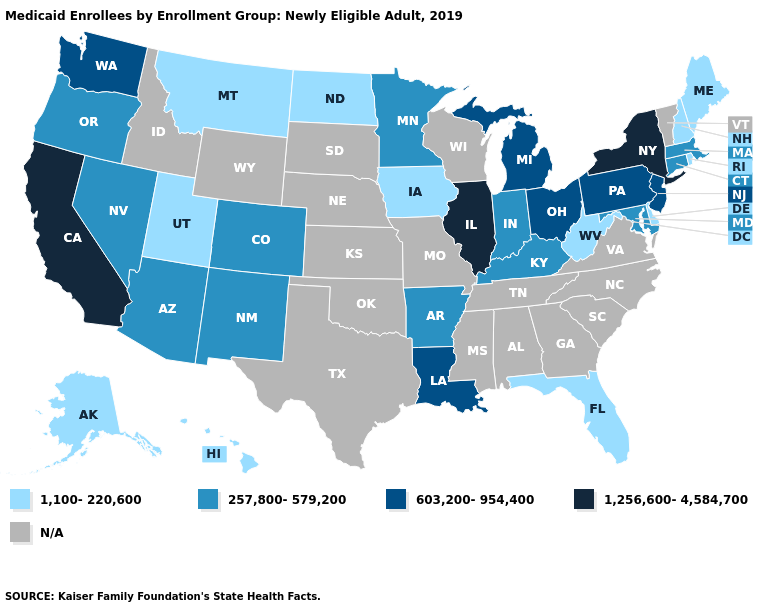Does Delaware have the lowest value in the USA?
Be succinct. Yes. Name the states that have a value in the range 1,256,600-4,584,700?
Be succinct. California, Illinois, New York. Does New Hampshire have the lowest value in the USA?
Short answer required. Yes. Name the states that have a value in the range 257,800-579,200?
Answer briefly. Arizona, Arkansas, Colorado, Connecticut, Indiana, Kentucky, Maryland, Massachusetts, Minnesota, Nevada, New Mexico, Oregon. What is the highest value in the USA?
Write a very short answer. 1,256,600-4,584,700. Name the states that have a value in the range 257,800-579,200?
Answer briefly. Arizona, Arkansas, Colorado, Connecticut, Indiana, Kentucky, Maryland, Massachusetts, Minnesota, Nevada, New Mexico, Oregon. What is the value of California?
Short answer required. 1,256,600-4,584,700. Does the map have missing data?
Keep it brief. Yes. Name the states that have a value in the range 603,200-954,400?
Keep it brief. Louisiana, Michigan, New Jersey, Ohio, Pennsylvania, Washington. What is the lowest value in the MidWest?
Keep it brief. 1,100-220,600. What is the highest value in the Northeast ?
Concise answer only. 1,256,600-4,584,700. 